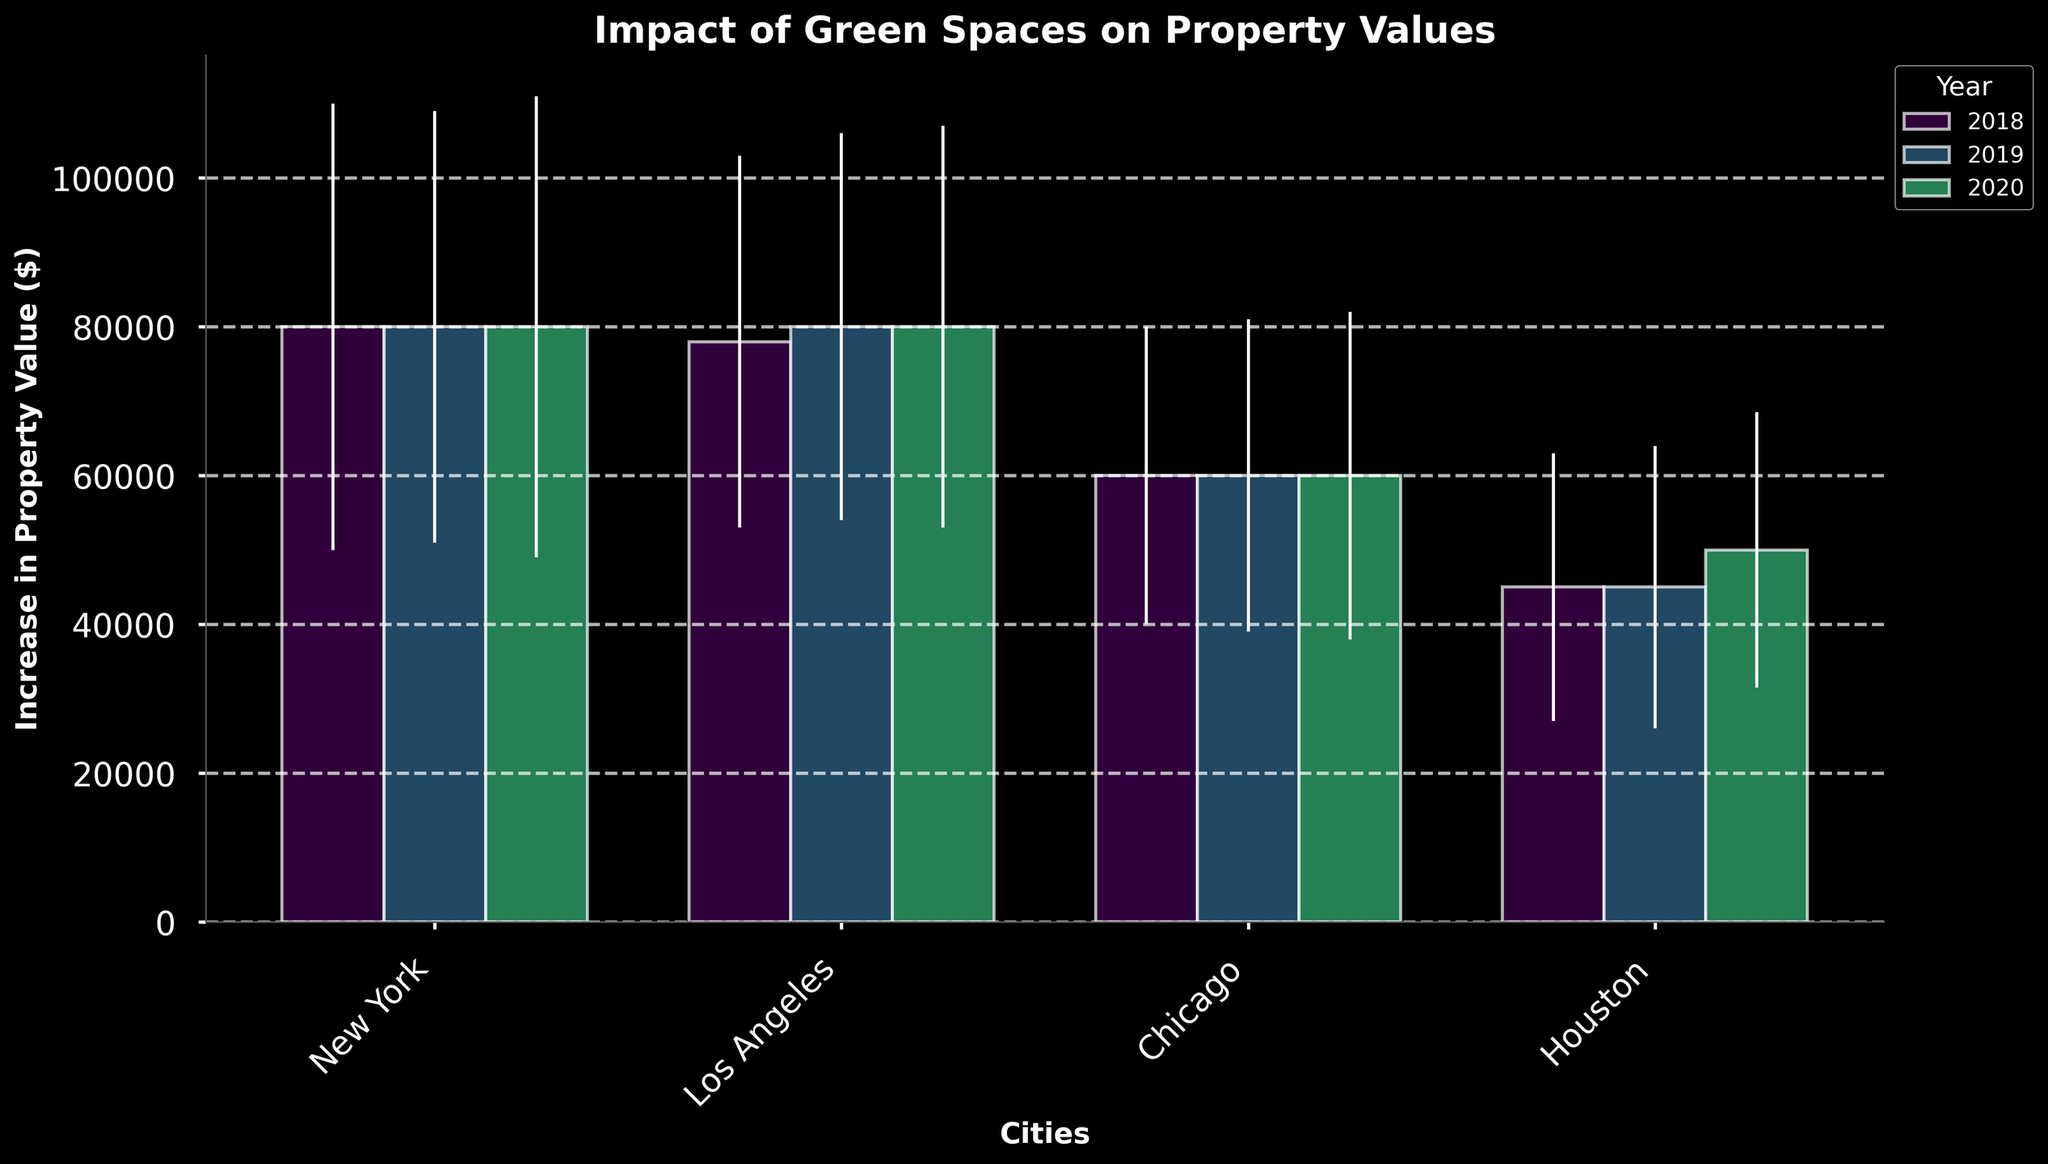What is the title of the figure? The title can be seen at the top of the figure and it summarizes the main topic of the chart.
Answer: Impact of Green Spaces on Property Values Which city experienced the highest increase in property value in 2018 due to green spaces? Look for the tallest bar in 2018 across the different cities.
Answer: New York How does the increase in property value in Los Angeles in 2019 compare to 2020? Compare the heights of the bars labeled 2019 and 2020 for Los Angeles.
Answer: The increase in 2020 is higher than in 2019 What is the average increase in property value across all the cities in 2020? Sum the increases for all cities in 2020 and divide by the number of cities.
Answer: 175,000 / 4 = 43,750 Which city has the least variation in the increase of property value across the years according to the error bars? Find the city with the shortest error bars, indicating the least variation.
Answer: Houston What does the x-axis represent in this figure? Examine the label below the axis that indicates what the bars are grouped by.
Answer: Cities How do the property value increases in Chicago in 2018 and 2020 compare? Compare the heights of the bars for Chicago in 2018 and 2020.
Answer: The increase in 2020 is higher than in 2018 Which year showed the highest average increase in property values across all cities? Compare the average increase values for each year by observing the heights of the bars in each group of years.
Answer: 2020 What is the increase in property value in Houston in 2019 due to green spaces? Check the height of the bar for Houston in 2019.
Answer: 45,000 Does any city show a significant decrease or inconsistency in property value increases over the years? Observe the patterns of error bars and variations in the heights of the bars across different years for each city.
Answer: No significant decreases or inconsistencies 